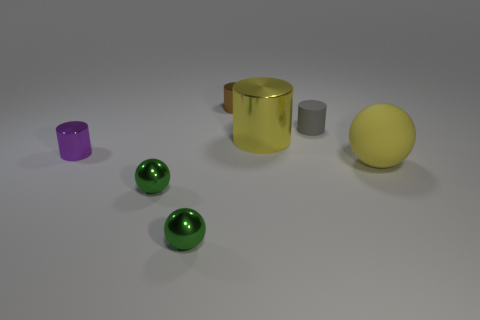How many large objects are yellow objects or yellow spheres?
Your answer should be compact. 2. Does the metal object to the right of the small brown cylinder have the same shape as the big yellow object that is to the right of the gray cylinder?
Offer a terse response. No. There is a shiny cylinder to the left of the tiny metallic object that is behind the big thing that is behind the purple shiny object; what is its size?
Give a very brief answer. Small. What size is the yellow object that is on the right side of the yellow shiny cylinder?
Provide a succinct answer. Large. There is a big yellow thing left of the tiny gray rubber cylinder; what is its material?
Your response must be concise. Metal. How many brown objects are metal objects or large balls?
Keep it short and to the point. 1. Do the gray cylinder and the yellow cylinder on the right side of the small brown metal cylinder have the same material?
Give a very brief answer. No. Is the number of large yellow cylinders that are to the right of the large yellow cylinder the same as the number of tiny brown metallic things to the left of the small purple shiny object?
Offer a very short reply. Yes. Is the size of the gray matte cylinder the same as the matte thing that is in front of the large yellow cylinder?
Your answer should be very brief. No. Is the number of large metallic objects that are in front of the small brown object greater than the number of large purple rubber objects?
Your response must be concise. Yes. 